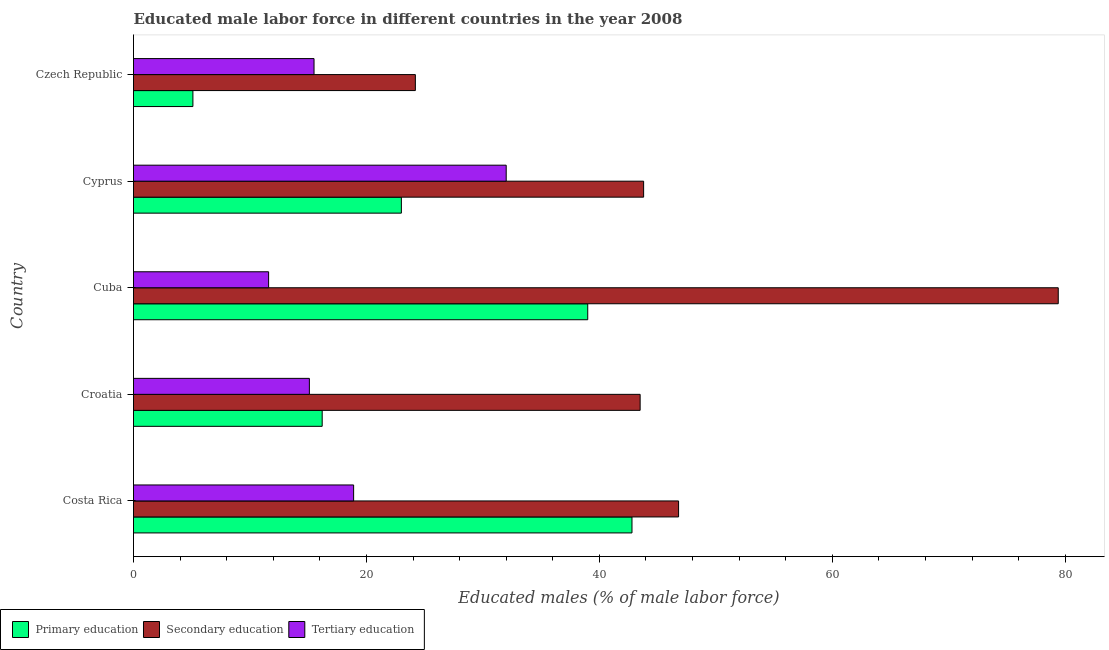How many different coloured bars are there?
Offer a very short reply. 3. How many groups of bars are there?
Give a very brief answer. 5. Are the number of bars per tick equal to the number of legend labels?
Offer a terse response. Yes. What is the label of the 3rd group of bars from the top?
Your answer should be compact. Cuba. In how many cases, is the number of bars for a given country not equal to the number of legend labels?
Keep it short and to the point. 0. What is the percentage of male labor force who received secondary education in Costa Rica?
Your answer should be compact. 46.8. Across all countries, what is the maximum percentage of male labor force who received primary education?
Make the answer very short. 42.8. Across all countries, what is the minimum percentage of male labor force who received secondary education?
Ensure brevity in your answer.  24.2. In which country was the percentage of male labor force who received secondary education maximum?
Your answer should be compact. Cuba. In which country was the percentage of male labor force who received tertiary education minimum?
Ensure brevity in your answer.  Cuba. What is the total percentage of male labor force who received secondary education in the graph?
Your answer should be compact. 237.7. What is the difference between the percentage of male labor force who received primary education in Costa Rica and the percentage of male labor force who received secondary education in Croatia?
Make the answer very short. -0.7. What is the average percentage of male labor force who received primary education per country?
Your response must be concise. 25.22. What is the difference between the percentage of male labor force who received tertiary education and percentage of male labor force who received secondary education in Croatia?
Keep it short and to the point. -28.4. What is the ratio of the percentage of male labor force who received tertiary education in Cuba to that in Czech Republic?
Your response must be concise. 0.75. Is the percentage of male labor force who received secondary education in Croatia less than that in Cyprus?
Give a very brief answer. Yes. Is the difference between the percentage of male labor force who received secondary education in Croatia and Czech Republic greater than the difference between the percentage of male labor force who received primary education in Croatia and Czech Republic?
Ensure brevity in your answer.  Yes. What is the difference between the highest and the second highest percentage of male labor force who received secondary education?
Offer a terse response. 32.6. What is the difference between the highest and the lowest percentage of male labor force who received secondary education?
Provide a short and direct response. 55.2. Is the sum of the percentage of male labor force who received primary education in Costa Rica and Cyprus greater than the maximum percentage of male labor force who received secondary education across all countries?
Your response must be concise. No. What does the 2nd bar from the bottom in Cyprus represents?
Make the answer very short. Secondary education. Is it the case that in every country, the sum of the percentage of male labor force who received primary education and percentage of male labor force who received secondary education is greater than the percentage of male labor force who received tertiary education?
Provide a short and direct response. Yes. How many bars are there?
Provide a succinct answer. 15. How many countries are there in the graph?
Provide a succinct answer. 5. What is the difference between two consecutive major ticks on the X-axis?
Offer a terse response. 20. Does the graph contain any zero values?
Make the answer very short. No. Does the graph contain grids?
Offer a very short reply. No. Where does the legend appear in the graph?
Keep it short and to the point. Bottom left. How many legend labels are there?
Keep it short and to the point. 3. How are the legend labels stacked?
Provide a short and direct response. Horizontal. What is the title of the graph?
Your response must be concise. Educated male labor force in different countries in the year 2008. Does "Natural Gas" appear as one of the legend labels in the graph?
Offer a very short reply. No. What is the label or title of the X-axis?
Keep it short and to the point. Educated males (% of male labor force). What is the Educated males (% of male labor force) in Primary education in Costa Rica?
Keep it short and to the point. 42.8. What is the Educated males (% of male labor force) in Secondary education in Costa Rica?
Your answer should be compact. 46.8. What is the Educated males (% of male labor force) in Tertiary education in Costa Rica?
Your response must be concise. 18.9. What is the Educated males (% of male labor force) in Primary education in Croatia?
Offer a terse response. 16.2. What is the Educated males (% of male labor force) in Secondary education in Croatia?
Offer a terse response. 43.5. What is the Educated males (% of male labor force) of Tertiary education in Croatia?
Keep it short and to the point. 15.1. What is the Educated males (% of male labor force) in Primary education in Cuba?
Provide a succinct answer. 39. What is the Educated males (% of male labor force) in Secondary education in Cuba?
Give a very brief answer. 79.4. What is the Educated males (% of male labor force) of Tertiary education in Cuba?
Keep it short and to the point. 11.6. What is the Educated males (% of male labor force) of Primary education in Cyprus?
Give a very brief answer. 23. What is the Educated males (% of male labor force) in Secondary education in Cyprus?
Offer a very short reply. 43.8. What is the Educated males (% of male labor force) in Tertiary education in Cyprus?
Offer a very short reply. 32. What is the Educated males (% of male labor force) of Primary education in Czech Republic?
Your answer should be compact. 5.1. What is the Educated males (% of male labor force) of Secondary education in Czech Republic?
Keep it short and to the point. 24.2. Across all countries, what is the maximum Educated males (% of male labor force) in Primary education?
Your response must be concise. 42.8. Across all countries, what is the maximum Educated males (% of male labor force) in Secondary education?
Your answer should be very brief. 79.4. Across all countries, what is the minimum Educated males (% of male labor force) of Primary education?
Your answer should be very brief. 5.1. Across all countries, what is the minimum Educated males (% of male labor force) of Secondary education?
Make the answer very short. 24.2. Across all countries, what is the minimum Educated males (% of male labor force) of Tertiary education?
Offer a very short reply. 11.6. What is the total Educated males (% of male labor force) in Primary education in the graph?
Your answer should be compact. 126.1. What is the total Educated males (% of male labor force) of Secondary education in the graph?
Your answer should be compact. 237.7. What is the total Educated males (% of male labor force) of Tertiary education in the graph?
Give a very brief answer. 93.1. What is the difference between the Educated males (% of male labor force) of Primary education in Costa Rica and that in Croatia?
Your response must be concise. 26.6. What is the difference between the Educated males (% of male labor force) of Primary education in Costa Rica and that in Cuba?
Ensure brevity in your answer.  3.8. What is the difference between the Educated males (% of male labor force) in Secondary education in Costa Rica and that in Cuba?
Your answer should be compact. -32.6. What is the difference between the Educated males (% of male labor force) in Tertiary education in Costa Rica and that in Cuba?
Provide a short and direct response. 7.3. What is the difference between the Educated males (% of male labor force) in Primary education in Costa Rica and that in Cyprus?
Your answer should be compact. 19.8. What is the difference between the Educated males (% of male labor force) in Secondary education in Costa Rica and that in Cyprus?
Provide a short and direct response. 3. What is the difference between the Educated males (% of male labor force) in Primary education in Costa Rica and that in Czech Republic?
Provide a short and direct response. 37.7. What is the difference between the Educated males (% of male labor force) in Secondary education in Costa Rica and that in Czech Republic?
Give a very brief answer. 22.6. What is the difference between the Educated males (% of male labor force) of Primary education in Croatia and that in Cuba?
Offer a very short reply. -22.8. What is the difference between the Educated males (% of male labor force) of Secondary education in Croatia and that in Cuba?
Provide a succinct answer. -35.9. What is the difference between the Educated males (% of male labor force) in Tertiary education in Croatia and that in Cuba?
Make the answer very short. 3.5. What is the difference between the Educated males (% of male labor force) of Primary education in Croatia and that in Cyprus?
Your response must be concise. -6.8. What is the difference between the Educated males (% of male labor force) of Tertiary education in Croatia and that in Cyprus?
Provide a short and direct response. -16.9. What is the difference between the Educated males (% of male labor force) in Secondary education in Croatia and that in Czech Republic?
Offer a terse response. 19.3. What is the difference between the Educated males (% of male labor force) of Tertiary education in Croatia and that in Czech Republic?
Your answer should be very brief. -0.4. What is the difference between the Educated males (% of male labor force) in Primary education in Cuba and that in Cyprus?
Offer a terse response. 16. What is the difference between the Educated males (% of male labor force) of Secondary education in Cuba and that in Cyprus?
Offer a very short reply. 35.6. What is the difference between the Educated males (% of male labor force) of Tertiary education in Cuba and that in Cyprus?
Your response must be concise. -20.4. What is the difference between the Educated males (% of male labor force) in Primary education in Cuba and that in Czech Republic?
Provide a short and direct response. 33.9. What is the difference between the Educated males (% of male labor force) in Secondary education in Cuba and that in Czech Republic?
Give a very brief answer. 55.2. What is the difference between the Educated males (% of male labor force) of Primary education in Cyprus and that in Czech Republic?
Your answer should be very brief. 17.9. What is the difference between the Educated males (% of male labor force) of Secondary education in Cyprus and that in Czech Republic?
Your answer should be compact. 19.6. What is the difference between the Educated males (% of male labor force) in Tertiary education in Cyprus and that in Czech Republic?
Your answer should be compact. 16.5. What is the difference between the Educated males (% of male labor force) of Primary education in Costa Rica and the Educated males (% of male labor force) of Tertiary education in Croatia?
Offer a terse response. 27.7. What is the difference between the Educated males (% of male labor force) in Secondary education in Costa Rica and the Educated males (% of male labor force) in Tertiary education in Croatia?
Offer a very short reply. 31.7. What is the difference between the Educated males (% of male labor force) of Primary education in Costa Rica and the Educated males (% of male labor force) of Secondary education in Cuba?
Your response must be concise. -36.6. What is the difference between the Educated males (% of male labor force) in Primary education in Costa Rica and the Educated males (% of male labor force) in Tertiary education in Cuba?
Ensure brevity in your answer.  31.2. What is the difference between the Educated males (% of male labor force) in Secondary education in Costa Rica and the Educated males (% of male labor force) in Tertiary education in Cuba?
Offer a terse response. 35.2. What is the difference between the Educated males (% of male labor force) of Secondary education in Costa Rica and the Educated males (% of male labor force) of Tertiary education in Cyprus?
Offer a terse response. 14.8. What is the difference between the Educated males (% of male labor force) of Primary education in Costa Rica and the Educated males (% of male labor force) of Tertiary education in Czech Republic?
Give a very brief answer. 27.3. What is the difference between the Educated males (% of male labor force) in Secondary education in Costa Rica and the Educated males (% of male labor force) in Tertiary education in Czech Republic?
Provide a short and direct response. 31.3. What is the difference between the Educated males (% of male labor force) in Primary education in Croatia and the Educated males (% of male labor force) in Secondary education in Cuba?
Ensure brevity in your answer.  -63.2. What is the difference between the Educated males (% of male labor force) of Secondary education in Croatia and the Educated males (% of male labor force) of Tertiary education in Cuba?
Your response must be concise. 31.9. What is the difference between the Educated males (% of male labor force) in Primary education in Croatia and the Educated males (% of male labor force) in Secondary education in Cyprus?
Your answer should be compact. -27.6. What is the difference between the Educated males (% of male labor force) in Primary education in Croatia and the Educated males (% of male labor force) in Tertiary education in Cyprus?
Your answer should be very brief. -15.8. What is the difference between the Educated males (% of male labor force) of Secondary education in Croatia and the Educated males (% of male labor force) of Tertiary education in Cyprus?
Give a very brief answer. 11.5. What is the difference between the Educated males (% of male labor force) of Primary education in Cuba and the Educated males (% of male labor force) of Secondary education in Cyprus?
Provide a short and direct response. -4.8. What is the difference between the Educated males (% of male labor force) of Secondary education in Cuba and the Educated males (% of male labor force) of Tertiary education in Cyprus?
Keep it short and to the point. 47.4. What is the difference between the Educated males (% of male labor force) in Primary education in Cuba and the Educated males (% of male labor force) in Tertiary education in Czech Republic?
Your answer should be very brief. 23.5. What is the difference between the Educated males (% of male labor force) in Secondary education in Cuba and the Educated males (% of male labor force) in Tertiary education in Czech Republic?
Provide a succinct answer. 63.9. What is the difference between the Educated males (% of male labor force) in Primary education in Cyprus and the Educated males (% of male labor force) in Secondary education in Czech Republic?
Offer a terse response. -1.2. What is the difference between the Educated males (% of male labor force) of Secondary education in Cyprus and the Educated males (% of male labor force) of Tertiary education in Czech Republic?
Your response must be concise. 28.3. What is the average Educated males (% of male labor force) in Primary education per country?
Keep it short and to the point. 25.22. What is the average Educated males (% of male labor force) of Secondary education per country?
Make the answer very short. 47.54. What is the average Educated males (% of male labor force) in Tertiary education per country?
Your answer should be very brief. 18.62. What is the difference between the Educated males (% of male labor force) in Primary education and Educated males (% of male labor force) in Secondary education in Costa Rica?
Make the answer very short. -4. What is the difference between the Educated males (% of male labor force) of Primary education and Educated males (% of male labor force) of Tertiary education in Costa Rica?
Your response must be concise. 23.9. What is the difference between the Educated males (% of male labor force) in Secondary education and Educated males (% of male labor force) in Tertiary education in Costa Rica?
Give a very brief answer. 27.9. What is the difference between the Educated males (% of male labor force) in Primary education and Educated males (% of male labor force) in Secondary education in Croatia?
Your response must be concise. -27.3. What is the difference between the Educated males (% of male labor force) of Secondary education and Educated males (% of male labor force) of Tertiary education in Croatia?
Your answer should be very brief. 28.4. What is the difference between the Educated males (% of male labor force) in Primary education and Educated males (% of male labor force) in Secondary education in Cuba?
Give a very brief answer. -40.4. What is the difference between the Educated males (% of male labor force) of Primary education and Educated males (% of male labor force) of Tertiary education in Cuba?
Provide a succinct answer. 27.4. What is the difference between the Educated males (% of male labor force) in Secondary education and Educated males (% of male labor force) in Tertiary education in Cuba?
Give a very brief answer. 67.8. What is the difference between the Educated males (% of male labor force) of Primary education and Educated males (% of male labor force) of Secondary education in Cyprus?
Your answer should be very brief. -20.8. What is the difference between the Educated males (% of male labor force) in Primary education and Educated males (% of male labor force) in Tertiary education in Cyprus?
Keep it short and to the point. -9. What is the difference between the Educated males (% of male labor force) of Secondary education and Educated males (% of male labor force) of Tertiary education in Cyprus?
Provide a short and direct response. 11.8. What is the difference between the Educated males (% of male labor force) of Primary education and Educated males (% of male labor force) of Secondary education in Czech Republic?
Provide a short and direct response. -19.1. What is the difference between the Educated males (% of male labor force) in Primary education and Educated males (% of male labor force) in Tertiary education in Czech Republic?
Keep it short and to the point. -10.4. What is the difference between the Educated males (% of male labor force) in Secondary education and Educated males (% of male labor force) in Tertiary education in Czech Republic?
Provide a short and direct response. 8.7. What is the ratio of the Educated males (% of male labor force) of Primary education in Costa Rica to that in Croatia?
Your answer should be very brief. 2.64. What is the ratio of the Educated males (% of male labor force) in Secondary education in Costa Rica to that in Croatia?
Make the answer very short. 1.08. What is the ratio of the Educated males (% of male labor force) in Tertiary education in Costa Rica to that in Croatia?
Offer a very short reply. 1.25. What is the ratio of the Educated males (% of male labor force) of Primary education in Costa Rica to that in Cuba?
Give a very brief answer. 1.1. What is the ratio of the Educated males (% of male labor force) in Secondary education in Costa Rica to that in Cuba?
Offer a very short reply. 0.59. What is the ratio of the Educated males (% of male labor force) of Tertiary education in Costa Rica to that in Cuba?
Your answer should be very brief. 1.63. What is the ratio of the Educated males (% of male labor force) of Primary education in Costa Rica to that in Cyprus?
Offer a terse response. 1.86. What is the ratio of the Educated males (% of male labor force) of Secondary education in Costa Rica to that in Cyprus?
Ensure brevity in your answer.  1.07. What is the ratio of the Educated males (% of male labor force) of Tertiary education in Costa Rica to that in Cyprus?
Ensure brevity in your answer.  0.59. What is the ratio of the Educated males (% of male labor force) in Primary education in Costa Rica to that in Czech Republic?
Your answer should be compact. 8.39. What is the ratio of the Educated males (% of male labor force) of Secondary education in Costa Rica to that in Czech Republic?
Provide a short and direct response. 1.93. What is the ratio of the Educated males (% of male labor force) of Tertiary education in Costa Rica to that in Czech Republic?
Give a very brief answer. 1.22. What is the ratio of the Educated males (% of male labor force) of Primary education in Croatia to that in Cuba?
Keep it short and to the point. 0.42. What is the ratio of the Educated males (% of male labor force) of Secondary education in Croatia to that in Cuba?
Provide a short and direct response. 0.55. What is the ratio of the Educated males (% of male labor force) of Tertiary education in Croatia to that in Cuba?
Offer a very short reply. 1.3. What is the ratio of the Educated males (% of male labor force) of Primary education in Croatia to that in Cyprus?
Make the answer very short. 0.7. What is the ratio of the Educated males (% of male labor force) in Secondary education in Croatia to that in Cyprus?
Give a very brief answer. 0.99. What is the ratio of the Educated males (% of male labor force) in Tertiary education in Croatia to that in Cyprus?
Provide a succinct answer. 0.47. What is the ratio of the Educated males (% of male labor force) of Primary education in Croatia to that in Czech Republic?
Your answer should be compact. 3.18. What is the ratio of the Educated males (% of male labor force) in Secondary education in Croatia to that in Czech Republic?
Offer a very short reply. 1.8. What is the ratio of the Educated males (% of male labor force) in Tertiary education in Croatia to that in Czech Republic?
Your answer should be compact. 0.97. What is the ratio of the Educated males (% of male labor force) in Primary education in Cuba to that in Cyprus?
Provide a short and direct response. 1.7. What is the ratio of the Educated males (% of male labor force) of Secondary education in Cuba to that in Cyprus?
Make the answer very short. 1.81. What is the ratio of the Educated males (% of male labor force) of Tertiary education in Cuba to that in Cyprus?
Offer a very short reply. 0.36. What is the ratio of the Educated males (% of male labor force) of Primary education in Cuba to that in Czech Republic?
Provide a short and direct response. 7.65. What is the ratio of the Educated males (% of male labor force) in Secondary education in Cuba to that in Czech Republic?
Ensure brevity in your answer.  3.28. What is the ratio of the Educated males (% of male labor force) in Tertiary education in Cuba to that in Czech Republic?
Your response must be concise. 0.75. What is the ratio of the Educated males (% of male labor force) in Primary education in Cyprus to that in Czech Republic?
Make the answer very short. 4.51. What is the ratio of the Educated males (% of male labor force) in Secondary education in Cyprus to that in Czech Republic?
Your answer should be very brief. 1.81. What is the ratio of the Educated males (% of male labor force) in Tertiary education in Cyprus to that in Czech Republic?
Provide a short and direct response. 2.06. What is the difference between the highest and the second highest Educated males (% of male labor force) in Primary education?
Your response must be concise. 3.8. What is the difference between the highest and the second highest Educated males (% of male labor force) of Secondary education?
Your response must be concise. 32.6. What is the difference between the highest and the lowest Educated males (% of male labor force) in Primary education?
Provide a succinct answer. 37.7. What is the difference between the highest and the lowest Educated males (% of male labor force) of Secondary education?
Your answer should be compact. 55.2. What is the difference between the highest and the lowest Educated males (% of male labor force) of Tertiary education?
Keep it short and to the point. 20.4. 